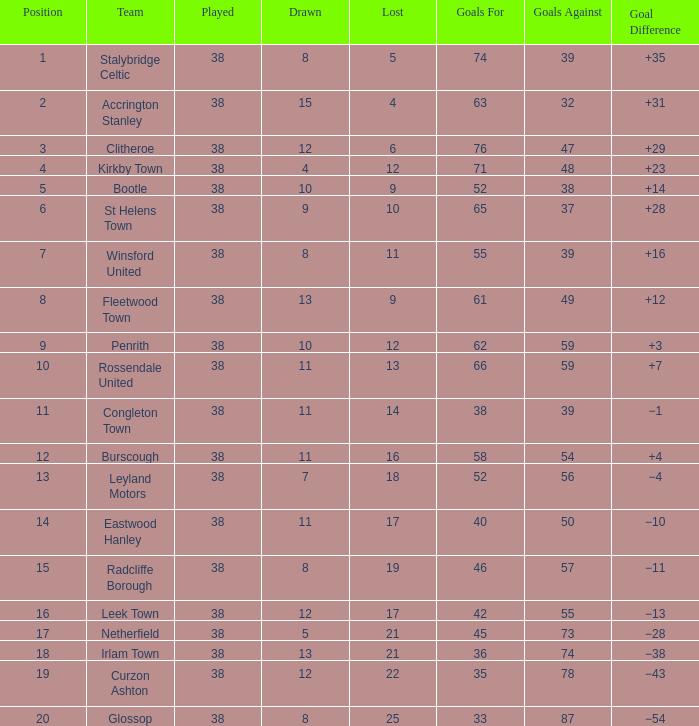What is the total number of goals that has been played less than 38 times? 0.0. 